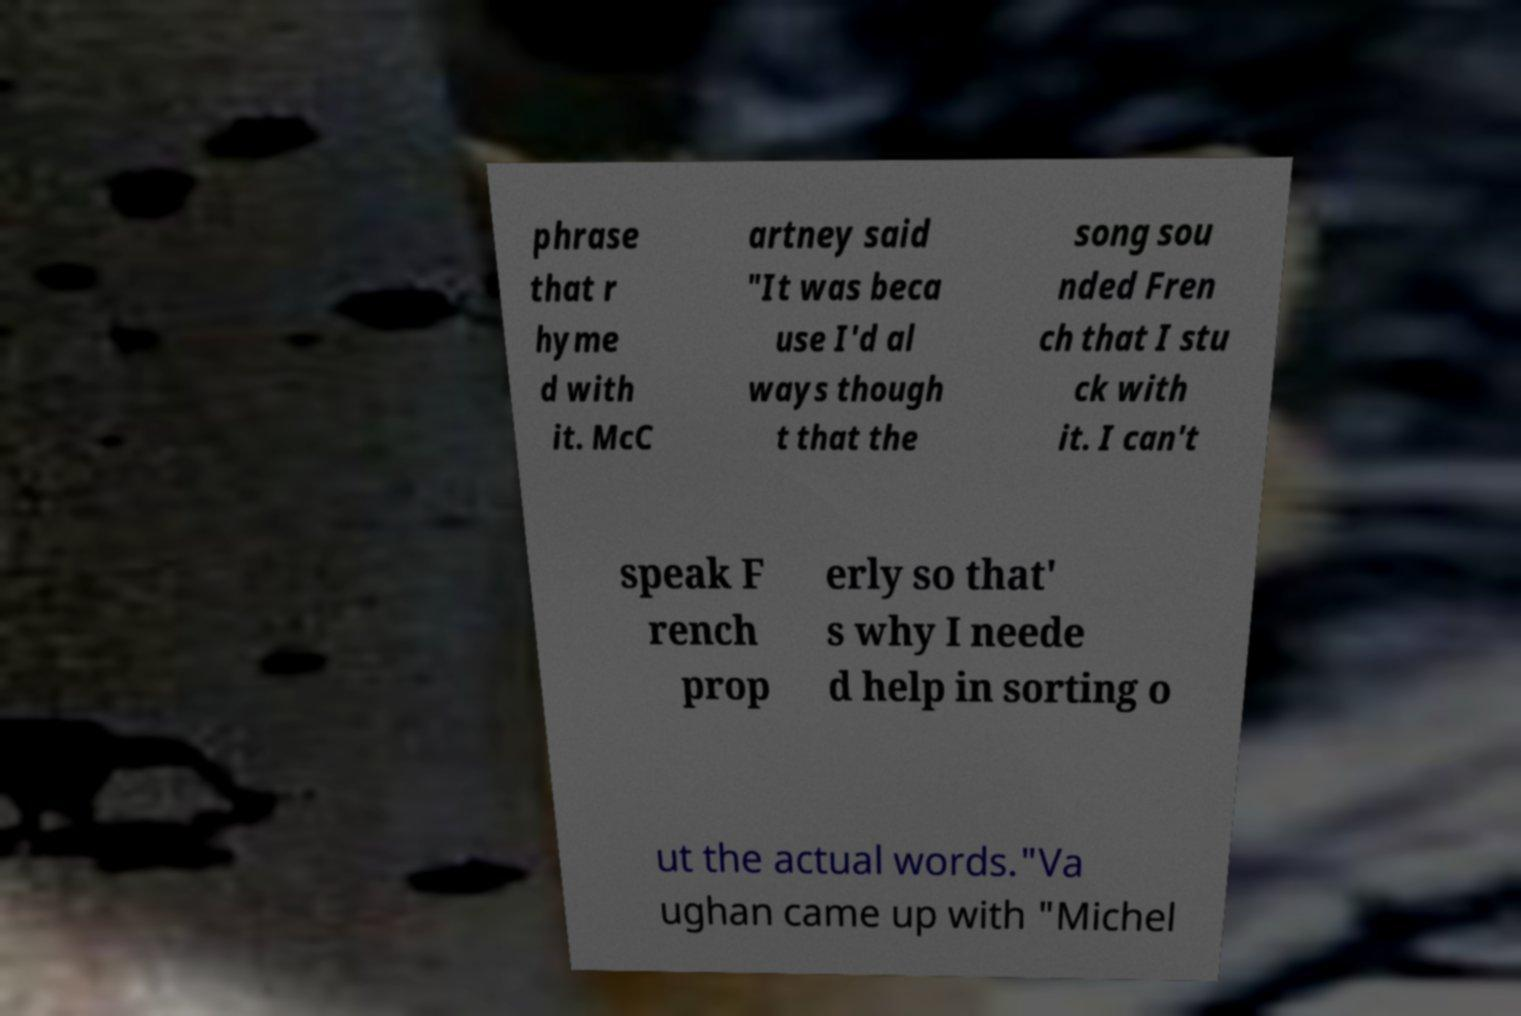Please read and relay the text visible in this image. What does it say? phrase that r hyme d with it. McC artney said "It was beca use I'd al ways though t that the song sou nded Fren ch that I stu ck with it. I can't speak F rench prop erly so that' s why I neede d help in sorting o ut the actual words."Va ughan came up with "Michel 